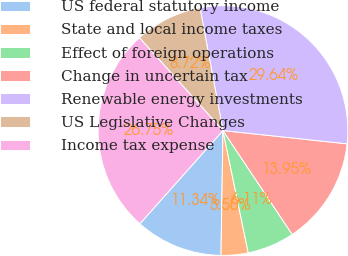Convert chart to OTSL. <chart><loc_0><loc_0><loc_500><loc_500><pie_chart><fcel>US federal statutory income<fcel>State and local income taxes<fcel>Effect of foreign operations<fcel>Change in uncertain tax<fcel>Renewable energy investments<fcel>US Legislative Changes<fcel>Income tax expense<nl><fcel>11.34%<fcel>3.5%<fcel>6.11%<fcel>13.95%<fcel>29.64%<fcel>8.72%<fcel>26.75%<nl></chart> 